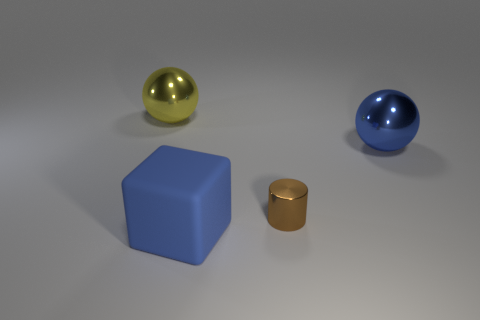Add 1 small brown cylinders. How many objects exist? 5 Subtract 0 gray spheres. How many objects are left? 4 Subtract all cylinders. How many objects are left? 3 Subtract all cyan cylinders. Subtract all yellow spheres. How many cylinders are left? 1 Subtract all green blocks. How many blue balls are left? 1 Subtract all green matte cubes. Subtract all blue blocks. How many objects are left? 3 Add 4 metal balls. How many metal balls are left? 6 Add 3 large yellow metal objects. How many large yellow metal objects exist? 4 